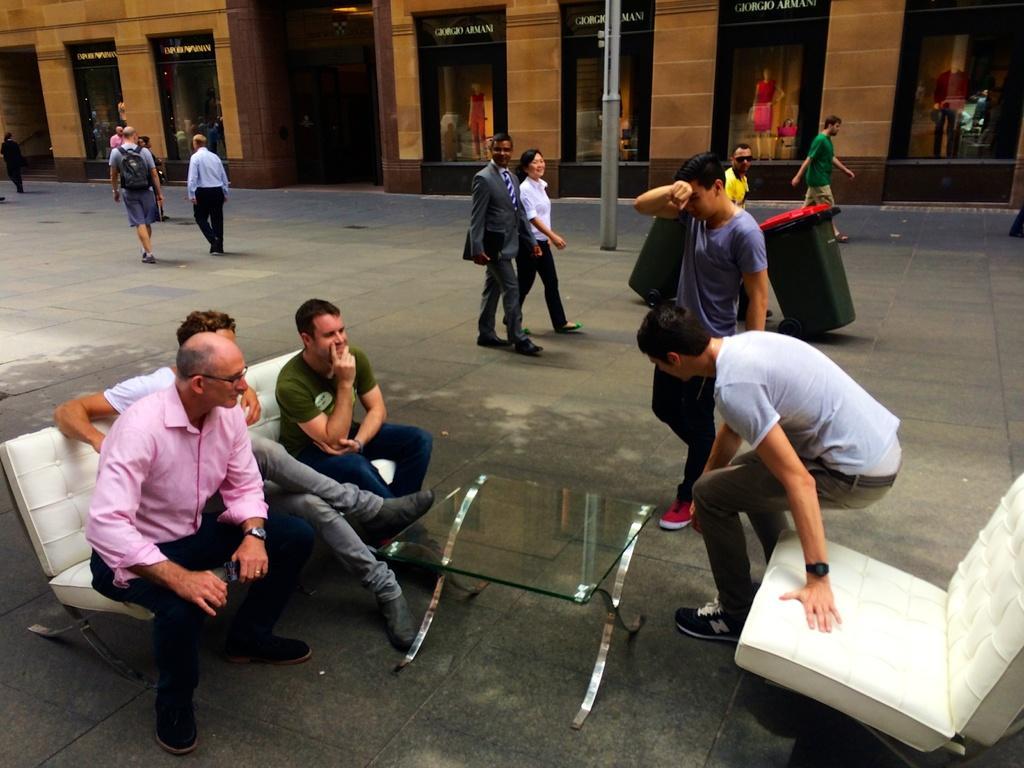Describe this image in one or two sentences. In this picture we can see groups of people, dustbins, a couch, table and a chair on the ground. There are some people sitting on the couch. Behind the people, there is a pole and there is a building with boards and glass doors. Inside the building, there are mannequins. 